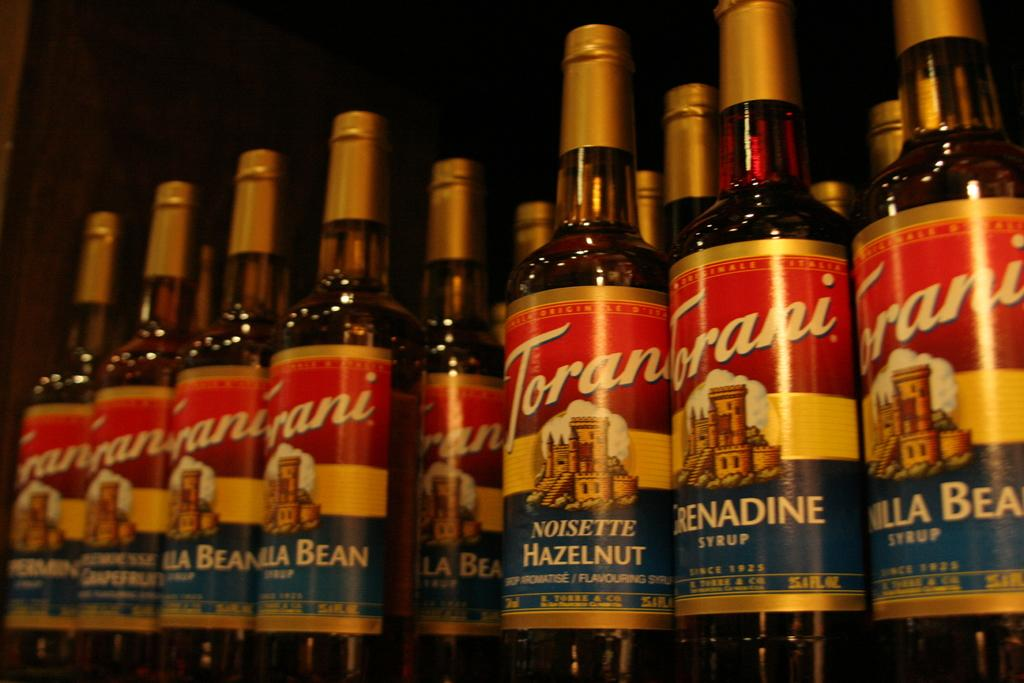Provide a one-sentence caption for the provided image. Several bottles of Hazlenut drink all stand side by side. 